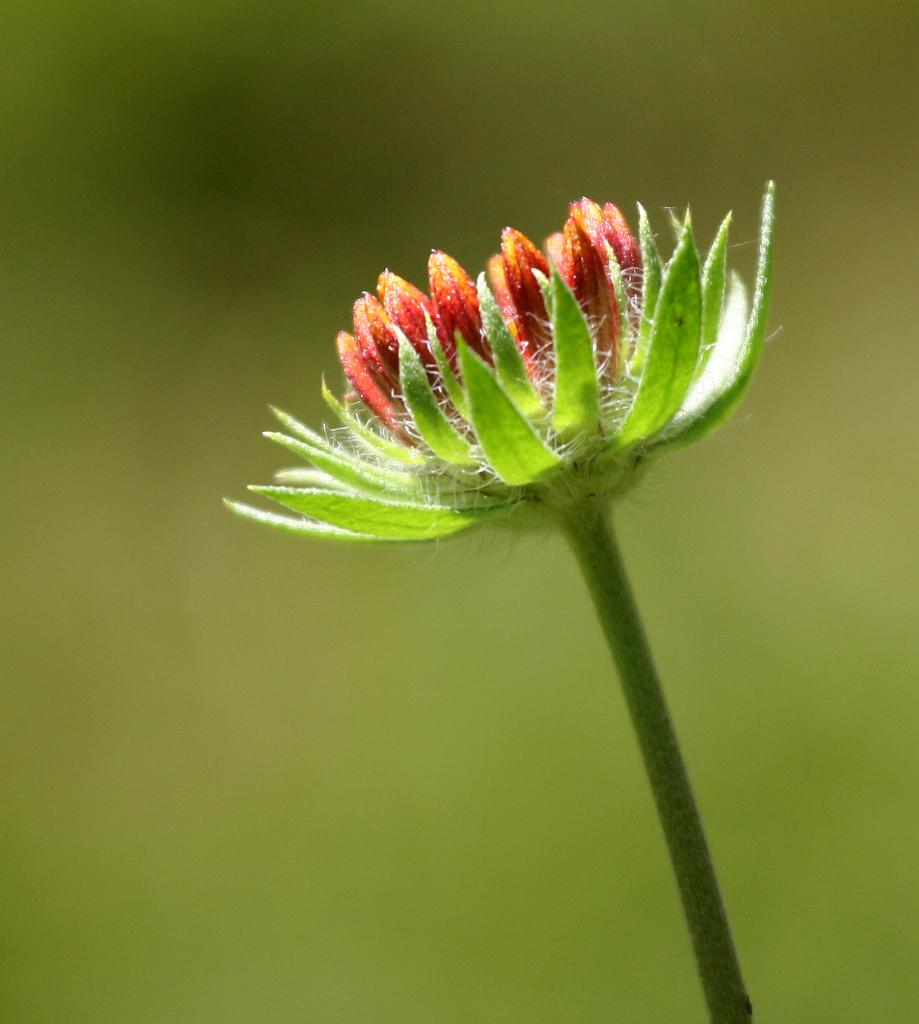What is the main subject of the image? There is a flower in the image. What color is the flower? The flower is red. What part of the flower is green? The flower has sepals in green color. How would you describe the background of the image? The background of the image is green and blurred. What type of coat is the flower wearing in the image? There is no coat present in the image, as flowers do not wear clothing. 